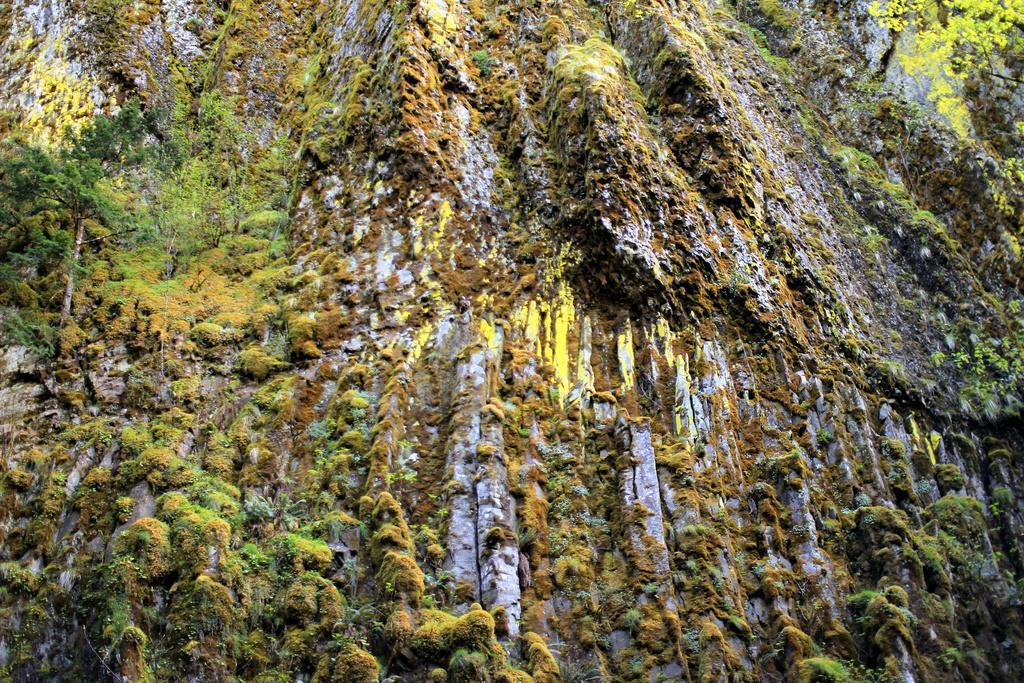Could you give a brief overview of what you see in this image? In this picture I can see there is a mountain and it is covered with trees. 